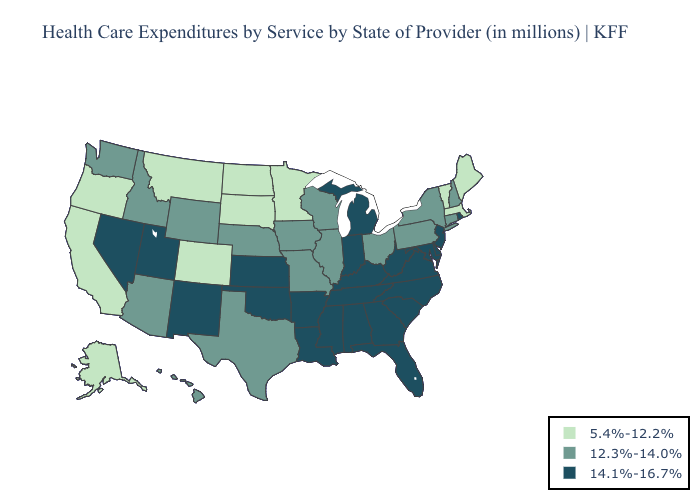What is the value of Georgia?
Be succinct. 14.1%-16.7%. Name the states that have a value in the range 12.3%-14.0%?
Keep it brief. Arizona, Connecticut, Hawaii, Idaho, Illinois, Iowa, Missouri, Nebraska, New Hampshire, New York, Ohio, Pennsylvania, Texas, Washington, Wisconsin, Wyoming. Name the states that have a value in the range 12.3%-14.0%?
Answer briefly. Arizona, Connecticut, Hawaii, Idaho, Illinois, Iowa, Missouri, Nebraska, New Hampshire, New York, Ohio, Pennsylvania, Texas, Washington, Wisconsin, Wyoming. Does South Carolina have the highest value in the USA?
Be succinct. Yes. Does the first symbol in the legend represent the smallest category?
Answer briefly. Yes. What is the highest value in the West ?
Concise answer only. 14.1%-16.7%. What is the lowest value in the West?
Quick response, please. 5.4%-12.2%. Name the states that have a value in the range 14.1%-16.7%?
Give a very brief answer. Alabama, Arkansas, Delaware, Florida, Georgia, Indiana, Kansas, Kentucky, Louisiana, Maryland, Michigan, Mississippi, Nevada, New Jersey, New Mexico, North Carolina, Oklahoma, Rhode Island, South Carolina, Tennessee, Utah, Virginia, West Virginia. What is the value of Wyoming?
Keep it brief. 12.3%-14.0%. How many symbols are there in the legend?
Quick response, please. 3. What is the lowest value in states that border Montana?
Write a very short answer. 5.4%-12.2%. Does Connecticut have a lower value than Oregon?
Short answer required. No. Name the states that have a value in the range 5.4%-12.2%?
Answer briefly. Alaska, California, Colorado, Maine, Massachusetts, Minnesota, Montana, North Dakota, Oregon, South Dakota, Vermont. Does Alabama have the highest value in the USA?
Short answer required. Yes. Name the states that have a value in the range 12.3%-14.0%?
Give a very brief answer. Arizona, Connecticut, Hawaii, Idaho, Illinois, Iowa, Missouri, Nebraska, New Hampshire, New York, Ohio, Pennsylvania, Texas, Washington, Wisconsin, Wyoming. 